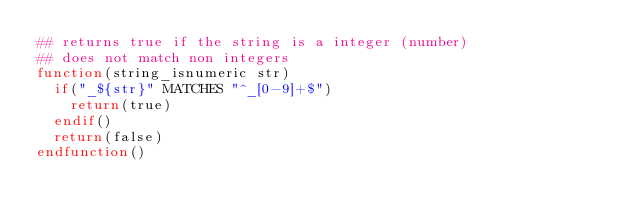Convert code to text. <code><loc_0><loc_0><loc_500><loc_500><_CMake_>## returns true if the string is a integer (number)
## does not match non integers
function(string_isnumeric str)
  if("_${str}" MATCHES "^_[0-9]+$")
    return(true)
  endif()
  return(false)
endfunction()</code> 